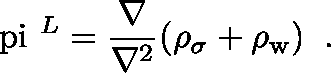<formula> <loc_0><loc_0><loc_500><loc_500>\boldmath \ p i ^ { L } = \frac { \nabla } { \nabla ^ { 2 } } ( \rho _ { \sigma } + \rho _ { w } ) \, .</formula> 